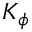Convert formula to latex. <formula><loc_0><loc_0><loc_500><loc_500>K _ { \phi }</formula> 